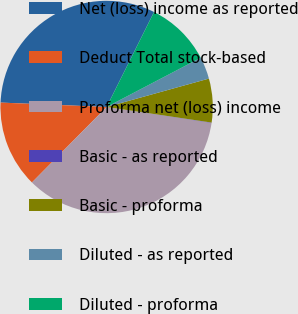Convert chart. <chart><loc_0><loc_0><loc_500><loc_500><pie_chart><fcel>Net (loss) income as reported<fcel>Deduct Total stock-based<fcel>Proforma net (loss) income<fcel>Basic - as reported<fcel>Basic - proforma<fcel>Diluted - as reported<fcel>Diluted - proforma<nl><fcel>31.71%<fcel>13.25%<fcel>35.01%<fcel>0.06%<fcel>6.66%<fcel>3.36%<fcel>9.96%<nl></chart> 